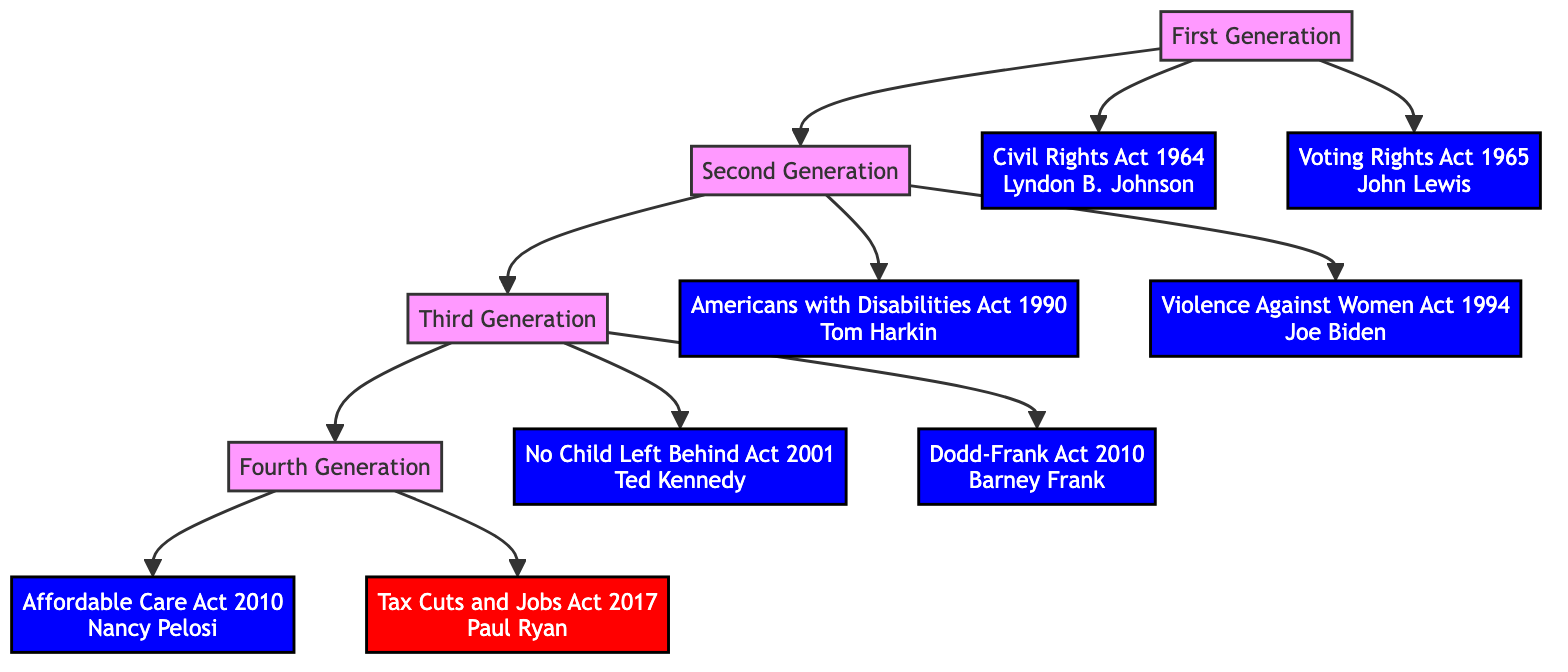What legislative act was proposed by Lyndon B. Johnson? In the diagram, the node connected to the First Generation, which lists Lyndon B. Johnson as a proponent, corresponds to the Civil Rights Act of 1964.
Answer: Civil Rights Act of 1964 How many generations are represented in the diagram? The diagram showcases four generations (First Generation, Second Generation, Third Generation, and Fourth Generation), as depicted by the nodes at the top of the flowchart.
Answer: 4 Which party was responsible for the Voting Rights Act of 1965? In the diagram, the Voting Rights Act of 1965 is associated with John Lewis, who is identified as a member of the Democratic Party.
Answer: Democratic Party Name one legislative act from the Fourth Generation. The Fourth Generation includes two acts, and either the Affordable Care Act of 2010 or the Tax Cuts and Jobs Act of 2017 can be identified as one of them.
Answer: Affordable Care Act of 2010 Which legislative act did Tom Harkin propose? The diagram clearly shows that Tom Harkin is linked to the Americans with Disabilities Act of 1990, which is displayed under the Second Generation.
Answer: Americans with Disabilities Act of 1990 Which generation proposed the Dodd-Frank Act? By following the flow downwards, the Dodd-Frank Wall Street Reform and Consumer Protection Act is located in the Third Generation, indicating that it was proposed during this time.
Answer: Third Generation What party is Nancy Pelosi affiliated with regarding the Affordable Care Act? According to the diagram, Nancy Pelosi is linked to the Affordable Care Act, and she is identified as a member of the Democratic Party in that node.
Answer: Democratic Party Which two acts were proposed in the Second Generation? The Second Generation includes the Americans with Disabilities Act of 1990 and the Violence Against Women Act of 1994, both of which are specified under that generation in the diagram.
Answer: Americans with Disabilities Act of 1990, Violence Against Women Act of 1994 What is the relationship between the First and Fourth Generations? The diagram illustrates a direct lineage where each generation is connected to the next, indicating that the First Generation precedes and is linked to the Fourth Generation.
Answer: First Generation precedes Fourth Generation 